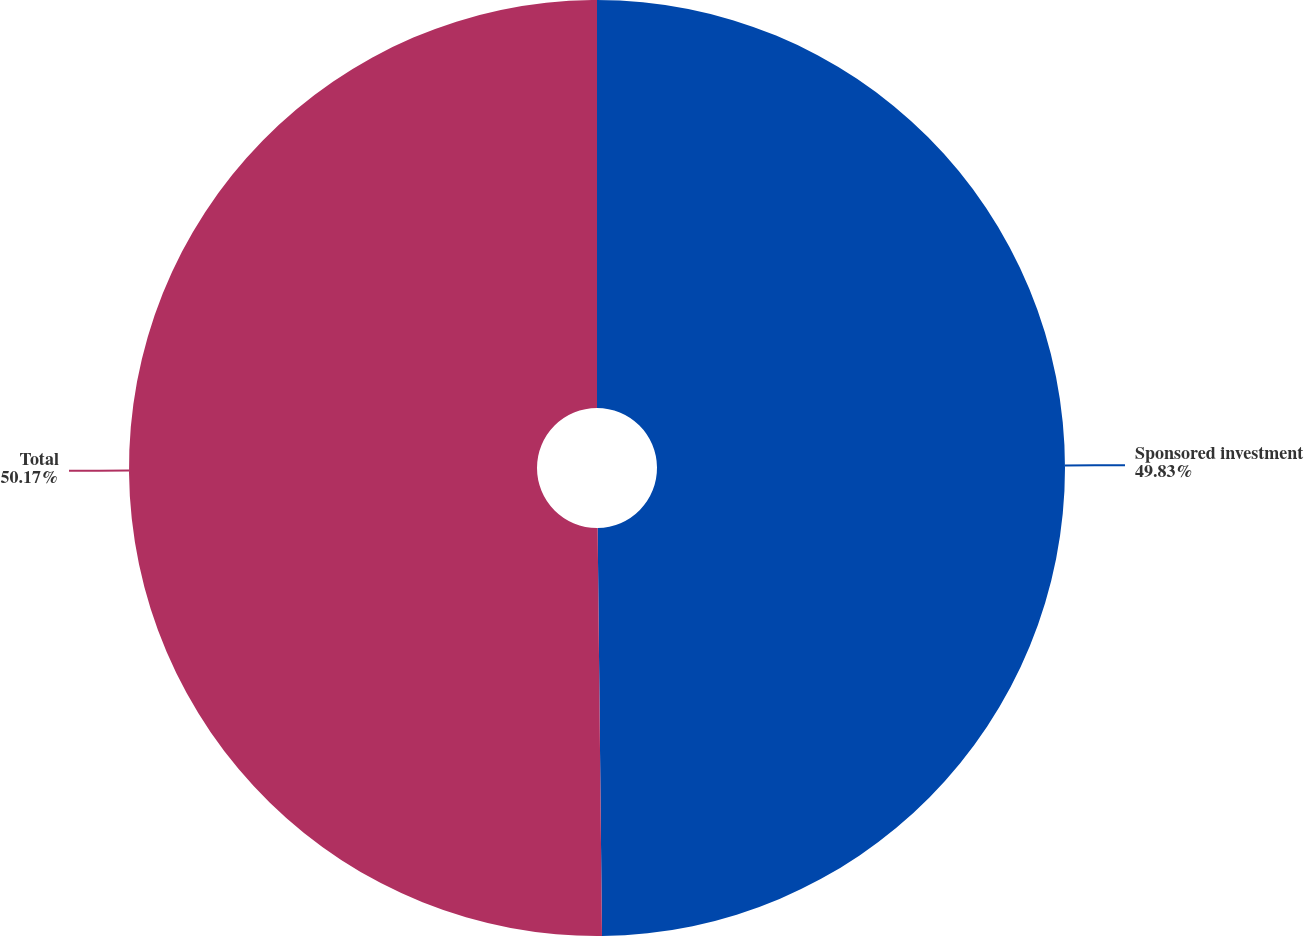Convert chart to OTSL. <chart><loc_0><loc_0><loc_500><loc_500><pie_chart><fcel>Sponsored investment<fcel>Total<nl><fcel>49.83%<fcel>50.17%<nl></chart> 